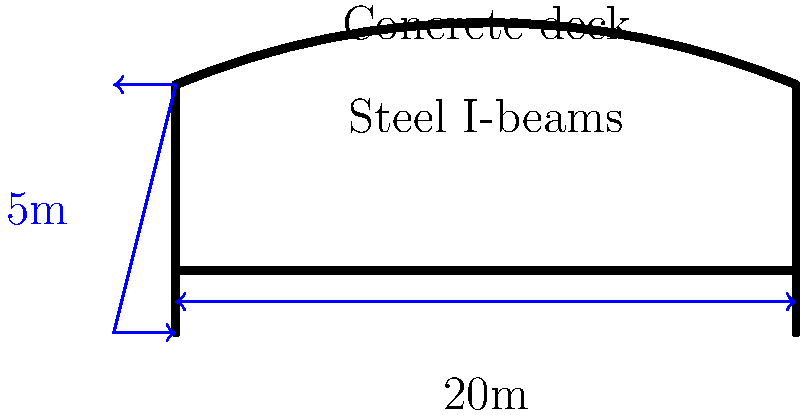As a parenting influencer, you're organizing a family-friendly community event on a newly constructed bridge. To ensure safety, you need to calculate the bridge's load-bearing capacity. Given a 20-meter long bridge with steel I-beams supporting a concrete deck, and assuming a safety factor of 1.5, what is the maximum number of people (average weight 70 kg) that can safely stand on the bridge if the calculated maximum load is 100,000 kg? To solve this problem, we'll follow these steps:

1. Understand the given information:
   - Bridge length: 20 meters
   - Calculated maximum load: 100,000 kg
   - Safety factor: 1.5
   - Average weight of a person: 70 kg

2. Calculate the safe load capacity:
   Safe load capacity = Maximum load ÷ Safety factor
   $$ \text{Safe load capacity} = \frac{100,000 \text{ kg}}{1.5} = 66,666.67 \text{ kg} $$

3. Calculate the number of people that can safely stand on the bridge:
   Number of people = Safe load capacity ÷ Average weight per person
   $$ \text{Number of people} = \frac{66,666.67 \text{ kg}}{70 \text{ kg/person}} = 952.38 \text{ people} $$

4. Round down to the nearest whole number for safety:
   Maximum number of people = 952

This calculation ensures that the bridge remains within its safe load-bearing capacity, considering the safety factor and the average weight of individuals attending your family-friendly event.
Answer: 952 people 